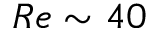<formula> <loc_0><loc_0><loc_500><loc_500>R e \sim 4 0</formula> 